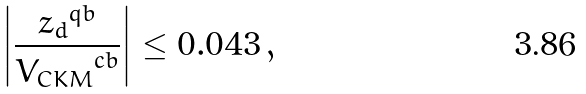Convert formula to latex. <formula><loc_0><loc_0><loc_500><loc_500>\left | \frac { { z _ { d } } ^ { q b } } { { V _ { C K M } } ^ { c b } } \right | \leq 0 . 0 4 3 \, ,</formula> 